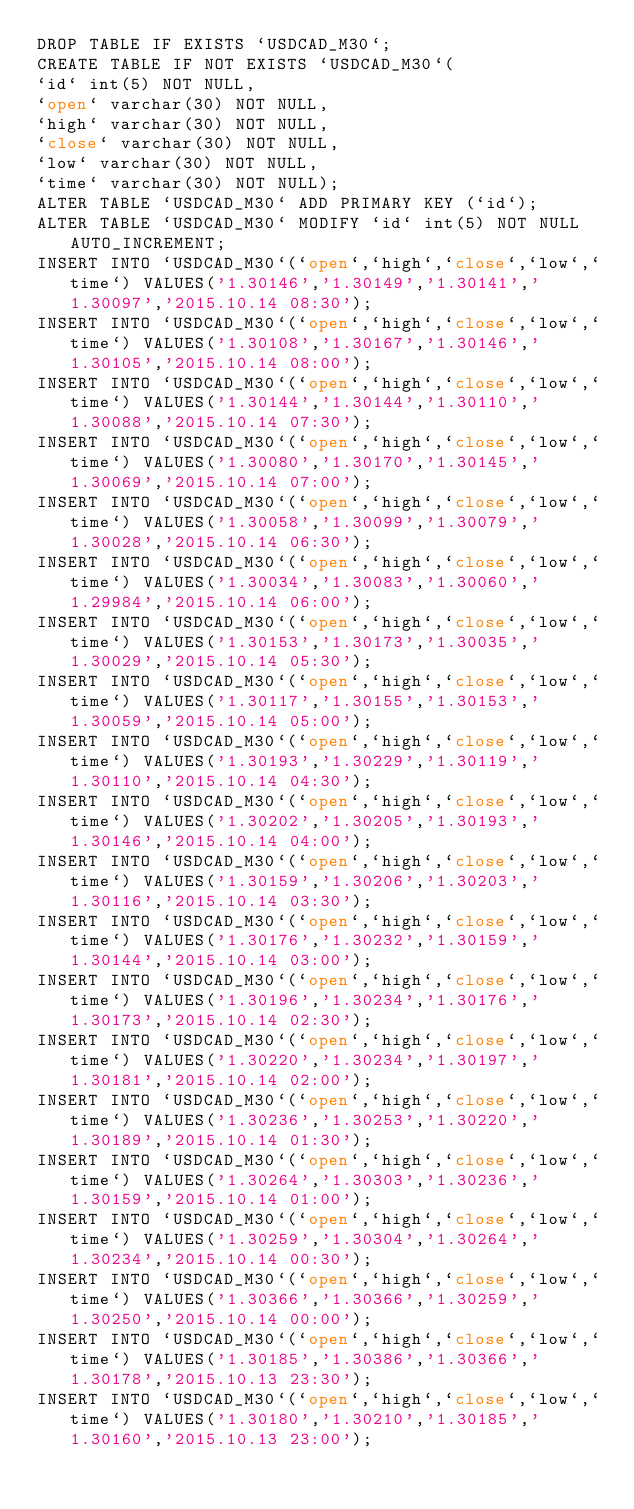Convert code to text. <code><loc_0><loc_0><loc_500><loc_500><_SQL_>DROP TABLE IF EXISTS `USDCAD_M30`;
CREATE TABLE IF NOT EXISTS `USDCAD_M30`(
`id` int(5) NOT NULL,
`open` varchar(30) NOT NULL,
`high` varchar(30) NOT NULL,
`close` varchar(30) NOT NULL,
`low` varchar(30) NOT NULL,
`time` varchar(30) NOT NULL);
ALTER TABLE `USDCAD_M30` ADD PRIMARY KEY (`id`);
ALTER TABLE `USDCAD_M30` MODIFY `id` int(5) NOT NULL AUTO_INCREMENT;
INSERT INTO `USDCAD_M30`(`open`,`high`,`close`,`low`,`time`) VALUES('1.30146','1.30149','1.30141','1.30097','2015.10.14 08:30');
INSERT INTO `USDCAD_M30`(`open`,`high`,`close`,`low`,`time`) VALUES('1.30108','1.30167','1.30146','1.30105','2015.10.14 08:00');
INSERT INTO `USDCAD_M30`(`open`,`high`,`close`,`low`,`time`) VALUES('1.30144','1.30144','1.30110','1.30088','2015.10.14 07:30');
INSERT INTO `USDCAD_M30`(`open`,`high`,`close`,`low`,`time`) VALUES('1.30080','1.30170','1.30145','1.30069','2015.10.14 07:00');
INSERT INTO `USDCAD_M30`(`open`,`high`,`close`,`low`,`time`) VALUES('1.30058','1.30099','1.30079','1.30028','2015.10.14 06:30');
INSERT INTO `USDCAD_M30`(`open`,`high`,`close`,`low`,`time`) VALUES('1.30034','1.30083','1.30060','1.29984','2015.10.14 06:00');
INSERT INTO `USDCAD_M30`(`open`,`high`,`close`,`low`,`time`) VALUES('1.30153','1.30173','1.30035','1.30029','2015.10.14 05:30');
INSERT INTO `USDCAD_M30`(`open`,`high`,`close`,`low`,`time`) VALUES('1.30117','1.30155','1.30153','1.30059','2015.10.14 05:00');
INSERT INTO `USDCAD_M30`(`open`,`high`,`close`,`low`,`time`) VALUES('1.30193','1.30229','1.30119','1.30110','2015.10.14 04:30');
INSERT INTO `USDCAD_M30`(`open`,`high`,`close`,`low`,`time`) VALUES('1.30202','1.30205','1.30193','1.30146','2015.10.14 04:00');
INSERT INTO `USDCAD_M30`(`open`,`high`,`close`,`low`,`time`) VALUES('1.30159','1.30206','1.30203','1.30116','2015.10.14 03:30');
INSERT INTO `USDCAD_M30`(`open`,`high`,`close`,`low`,`time`) VALUES('1.30176','1.30232','1.30159','1.30144','2015.10.14 03:00');
INSERT INTO `USDCAD_M30`(`open`,`high`,`close`,`low`,`time`) VALUES('1.30196','1.30234','1.30176','1.30173','2015.10.14 02:30');
INSERT INTO `USDCAD_M30`(`open`,`high`,`close`,`low`,`time`) VALUES('1.30220','1.30234','1.30197','1.30181','2015.10.14 02:00');
INSERT INTO `USDCAD_M30`(`open`,`high`,`close`,`low`,`time`) VALUES('1.30236','1.30253','1.30220','1.30189','2015.10.14 01:30');
INSERT INTO `USDCAD_M30`(`open`,`high`,`close`,`low`,`time`) VALUES('1.30264','1.30303','1.30236','1.30159','2015.10.14 01:00');
INSERT INTO `USDCAD_M30`(`open`,`high`,`close`,`low`,`time`) VALUES('1.30259','1.30304','1.30264','1.30234','2015.10.14 00:30');
INSERT INTO `USDCAD_M30`(`open`,`high`,`close`,`low`,`time`) VALUES('1.30366','1.30366','1.30259','1.30250','2015.10.14 00:00');
INSERT INTO `USDCAD_M30`(`open`,`high`,`close`,`low`,`time`) VALUES('1.30185','1.30386','1.30366','1.30178','2015.10.13 23:30');
INSERT INTO `USDCAD_M30`(`open`,`high`,`close`,`low`,`time`) VALUES('1.30180','1.30210','1.30185','1.30160','2015.10.13 23:00');</code> 